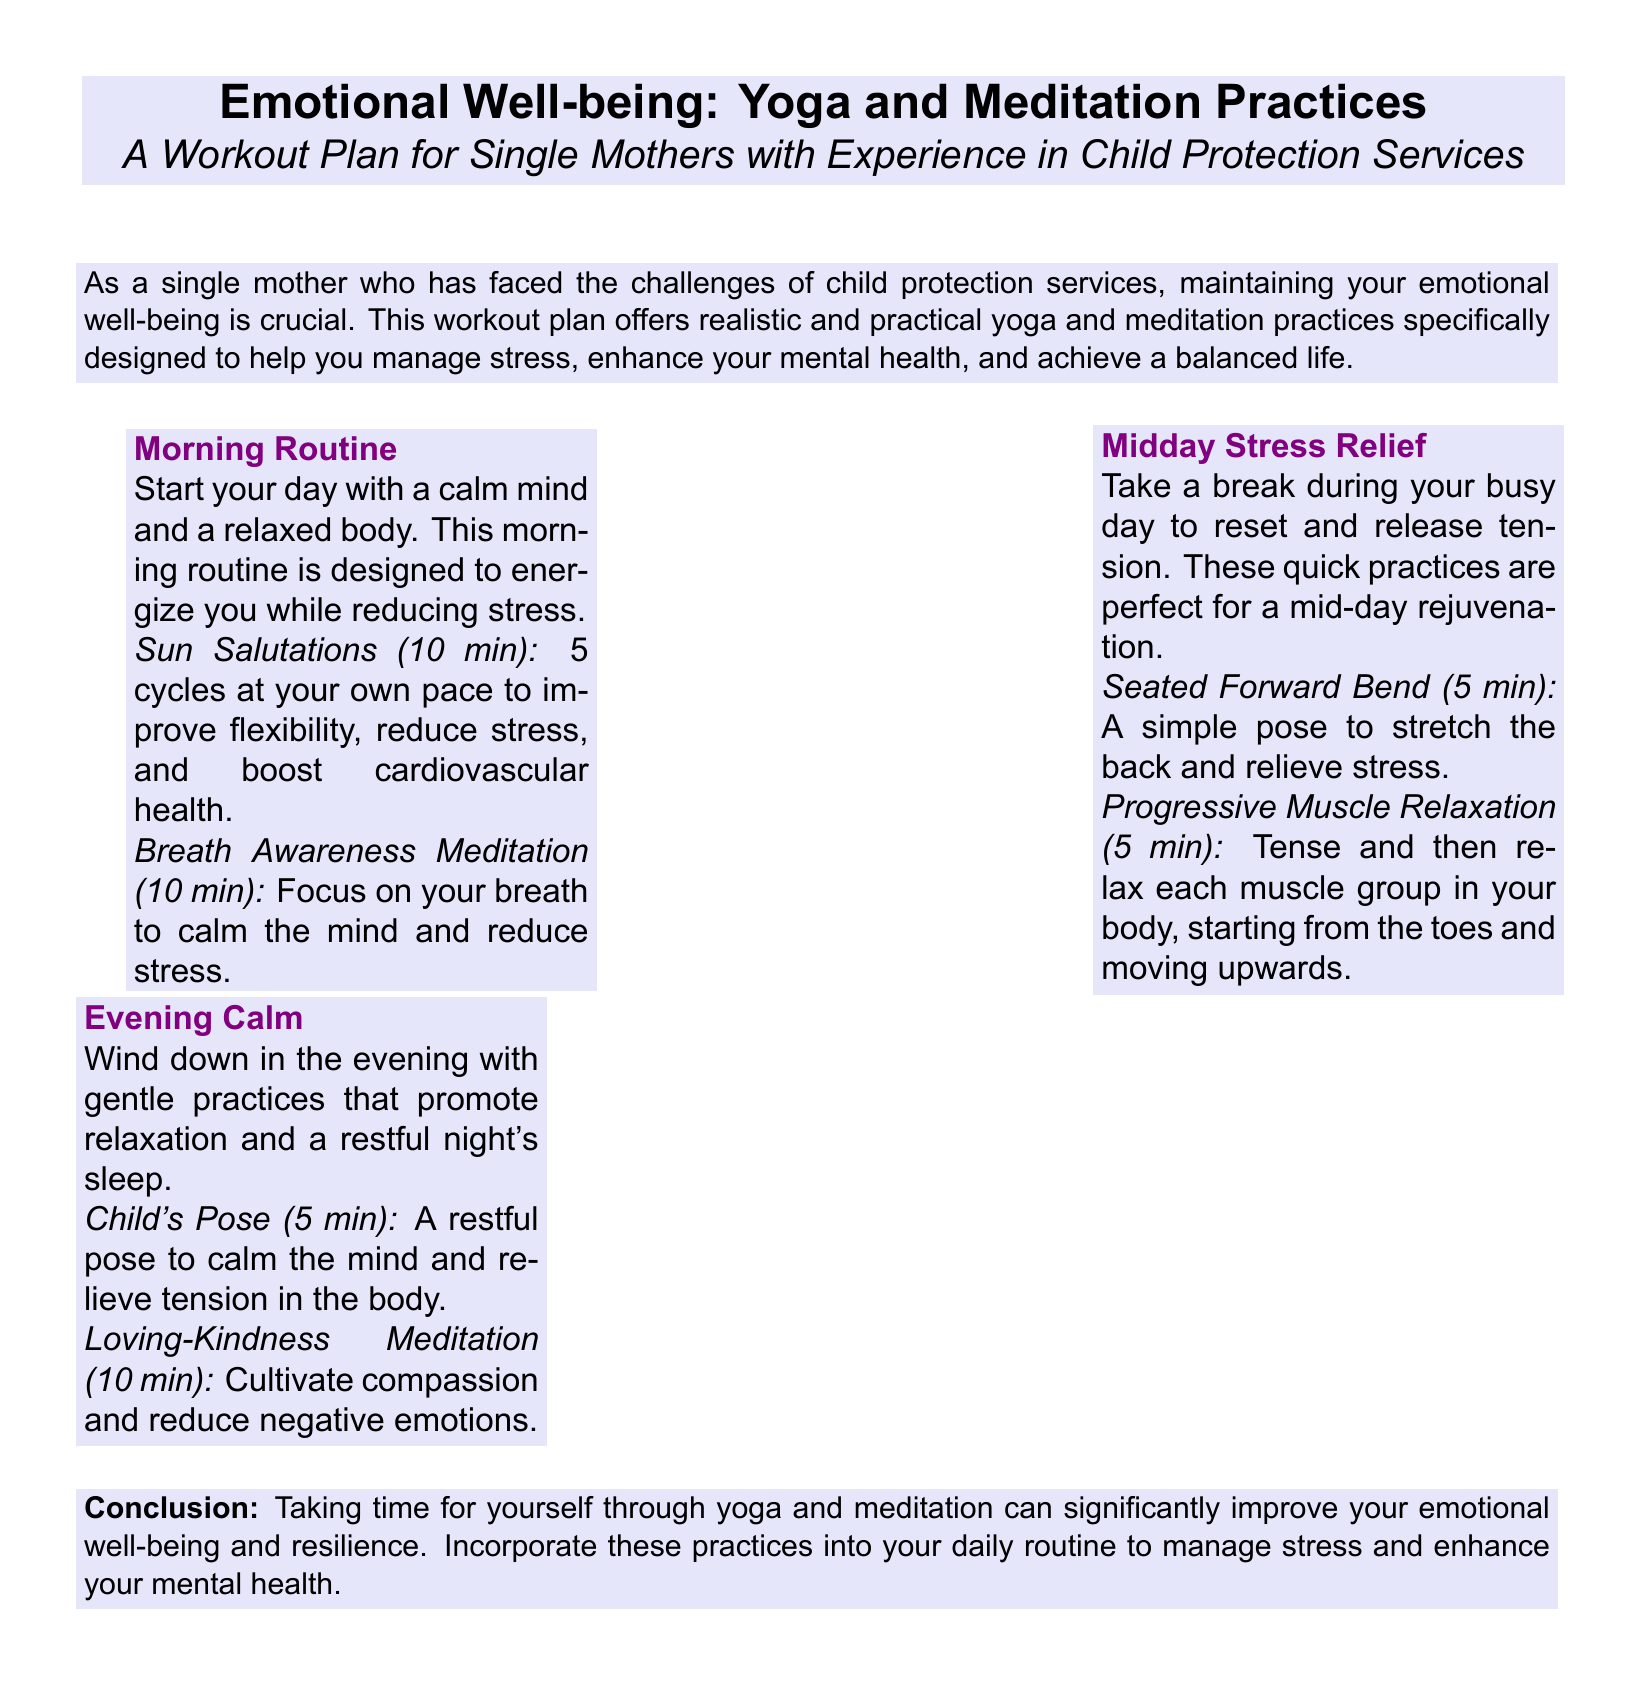What is the title of the workout plan? The title is stated at the beginning of the document, indicating the focus of the content.
Answer: Emotional Well-being: Yoga and Meditation Practices How long should the Sun Salutations be performed? The document specifies the duration for this practice in the morning routine section.
Answer: 10 min What is one of the practices included in the Midday Stress Relief section? This information can be found in the specific practices listed for this part of the workout plan.
Answer: Seated Forward Bend What is the purpose of the Loving-Kindness Meditation? The document describes the aim of this meditation within the context of the evening calm section.
Answer: Cultivate compassion How many cycles of Sun Salutations are recommended? The document explicitly states the number of cycles to perform.
Answer: 5 cycles What time of day is the Evening Calm section meant for? The section title indicates the time frame for these practices.
Answer: Evening What is emphasized as essential for single mothers in the conclusion? The conclusion summarizes the key message regarding the importance of a specific practice.
Answer: Taking time for yourself What is the recommended duration for Progressive Muscle Relaxation? The document details the time allocated to this practice in the midday section.
Answer: 5 min 